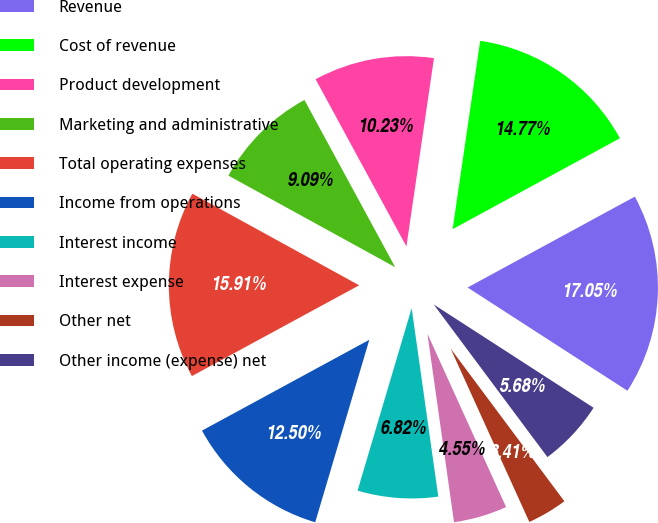Convert chart to OTSL. <chart><loc_0><loc_0><loc_500><loc_500><pie_chart><fcel>Revenue<fcel>Cost of revenue<fcel>Product development<fcel>Marketing and administrative<fcel>Total operating expenses<fcel>Income from operations<fcel>Interest income<fcel>Interest expense<fcel>Other net<fcel>Other income (expense) net<nl><fcel>17.05%<fcel>14.77%<fcel>10.23%<fcel>9.09%<fcel>15.91%<fcel>12.5%<fcel>6.82%<fcel>4.55%<fcel>3.41%<fcel>5.68%<nl></chart> 